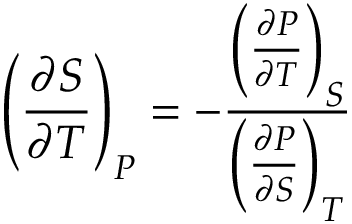<formula> <loc_0><loc_0><loc_500><loc_500>\left ( { \frac { \partial S } { \partial T } } \right ) _ { P } = - { \frac { \left ( { \frac { \partial P } { \partial T } } \right ) _ { S } } { \left ( { \frac { \partial P } { \partial S } } \right ) _ { T } } }</formula> 